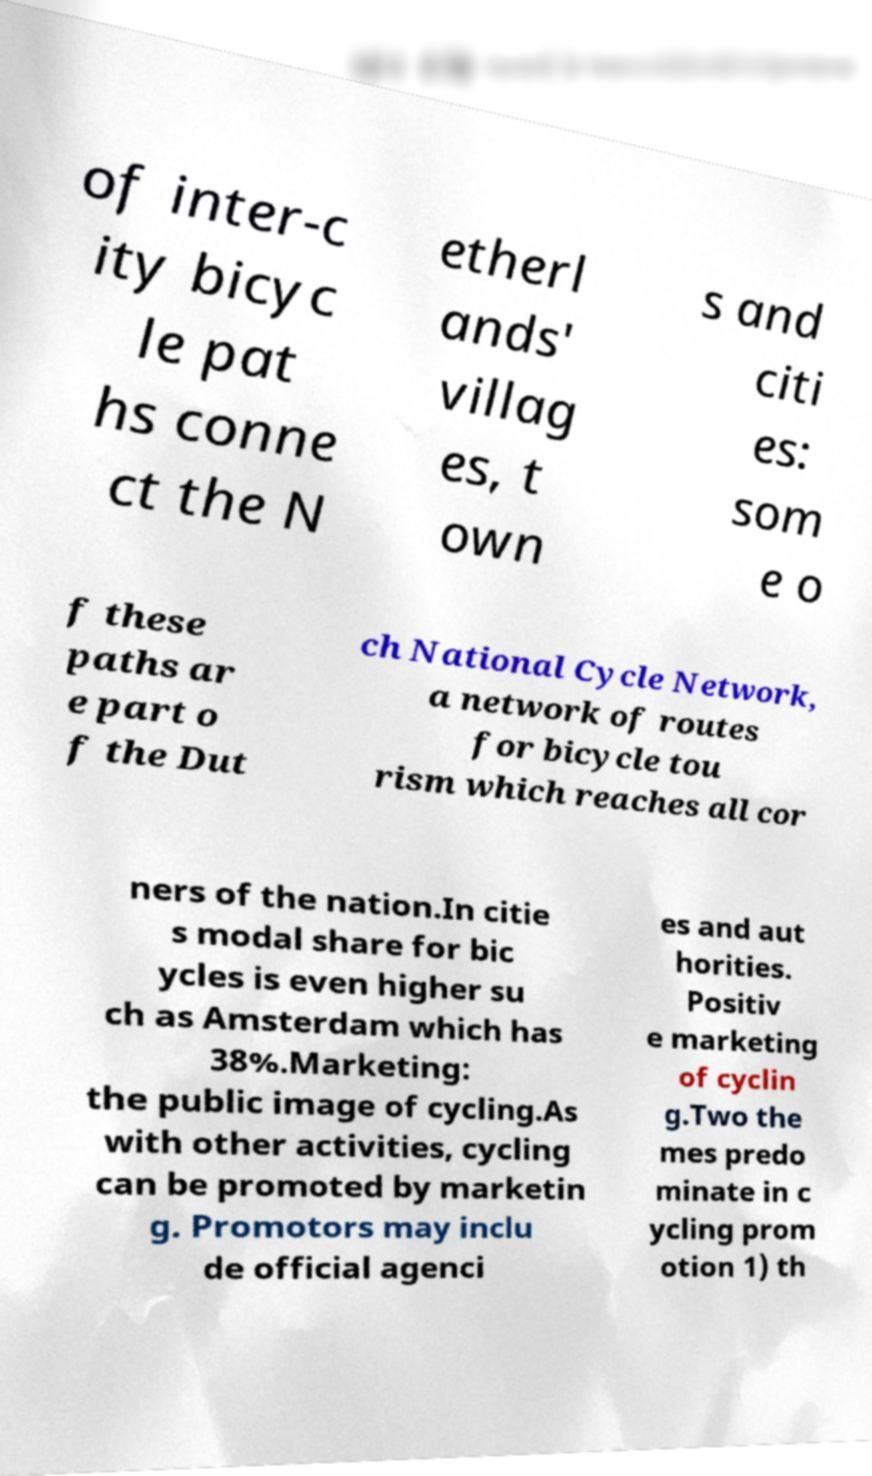I need the written content from this picture converted into text. Can you do that? of inter-c ity bicyc le pat hs conne ct the N etherl ands' villag es, t own s and citi es: som e o f these paths ar e part o f the Dut ch National Cycle Network, a network of routes for bicycle tou rism which reaches all cor ners of the nation.In citie s modal share for bic ycles is even higher su ch as Amsterdam which has 38%.Marketing: the public image of cycling.As with other activities, cycling can be promoted by marketin g. Promotors may inclu de official agenci es and aut horities. Positiv e marketing of cyclin g.Two the mes predo minate in c ycling prom otion 1) th 